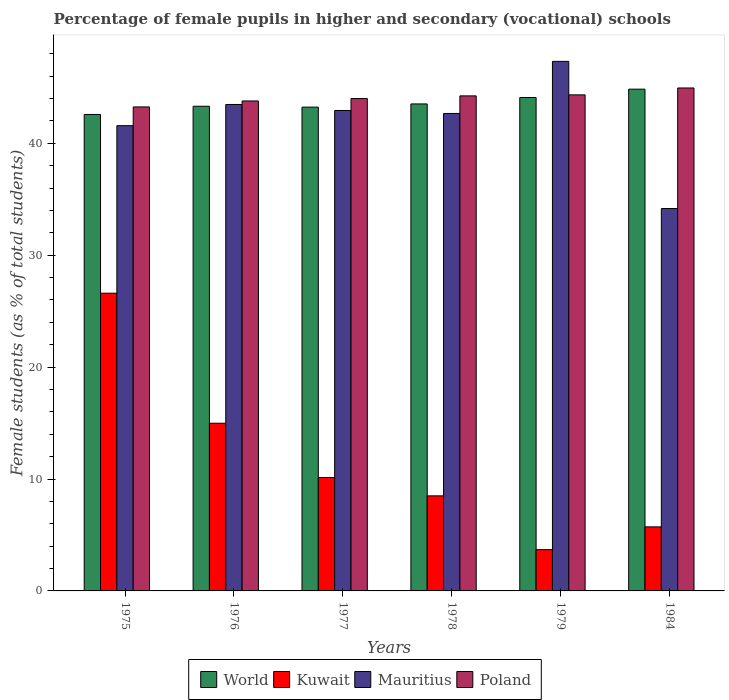How many different coloured bars are there?
Your answer should be compact. 4. How many groups of bars are there?
Your answer should be very brief. 6. Are the number of bars per tick equal to the number of legend labels?
Give a very brief answer. Yes. Are the number of bars on each tick of the X-axis equal?
Your response must be concise. Yes. How many bars are there on the 1st tick from the left?
Make the answer very short. 4. In how many cases, is the number of bars for a given year not equal to the number of legend labels?
Make the answer very short. 0. What is the percentage of female pupils in higher and secondary schools in Mauritius in 1984?
Your response must be concise. 34.17. Across all years, what is the maximum percentage of female pupils in higher and secondary schools in Kuwait?
Offer a terse response. 26.61. Across all years, what is the minimum percentage of female pupils in higher and secondary schools in Mauritius?
Offer a very short reply. 34.17. In which year was the percentage of female pupils in higher and secondary schools in Kuwait maximum?
Your answer should be compact. 1975. In which year was the percentage of female pupils in higher and secondary schools in Kuwait minimum?
Your answer should be compact. 1979. What is the total percentage of female pupils in higher and secondary schools in Poland in the graph?
Ensure brevity in your answer.  264.57. What is the difference between the percentage of female pupils in higher and secondary schools in Kuwait in 1976 and that in 1984?
Your response must be concise. 9.26. What is the difference between the percentage of female pupils in higher and secondary schools in Poland in 1978 and the percentage of female pupils in higher and secondary schools in World in 1979?
Give a very brief answer. 0.15. What is the average percentage of female pupils in higher and secondary schools in Poland per year?
Your answer should be very brief. 44.09. In the year 1977, what is the difference between the percentage of female pupils in higher and secondary schools in Poland and percentage of female pupils in higher and secondary schools in World?
Provide a short and direct response. 0.77. In how many years, is the percentage of female pupils in higher and secondary schools in Kuwait greater than 40 %?
Offer a terse response. 0. What is the ratio of the percentage of female pupils in higher and secondary schools in World in 1978 to that in 1984?
Provide a short and direct response. 0.97. Is the percentage of female pupils in higher and secondary schools in Kuwait in 1975 less than that in 1978?
Your response must be concise. No. Is the difference between the percentage of female pupils in higher and secondary schools in Poland in 1977 and 1984 greater than the difference between the percentage of female pupils in higher and secondary schools in World in 1977 and 1984?
Your answer should be compact. Yes. What is the difference between the highest and the second highest percentage of female pupils in higher and secondary schools in Mauritius?
Offer a terse response. 3.85. What is the difference between the highest and the lowest percentage of female pupils in higher and secondary schools in Kuwait?
Ensure brevity in your answer.  22.92. Is it the case that in every year, the sum of the percentage of female pupils in higher and secondary schools in Mauritius and percentage of female pupils in higher and secondary schools in Kuwait is greater than the sum of percentage of female pupils in higher and secondary schools in World and percentage of female pupils in higher and secondary schools in Poland?
Provide a short and direct response. No. What does the 1st bar from the left in 1975 represents?
Ensure brevity in your answer.  World. How many bars are there?
Your answer should be compact. 24. Are the values on the major ticks of Y-axis written in scientific E-notation?
Keep it short and to the point. No. Does the graph contain any zero values?
Make the answer very short. No. Does the graph contain grids?
Give a very brief answer. No. What is the title of the graph?
Give a very brief answer. Percentage of female pupils in higher and secondary (vocational) schools. Does "Faeroe Islands" appear as one of the legend labels in the graph?
Your answer should be compact. No. What is the label or title of the X-axis?
Offer a very short reply. Years. What is the label or title of the Y-axis?
Give a very brief answer. Female students (as % of total students). What is the Female students (as % of total students) of World in 1975?
Provide a short and direct response. 42.58. What is the Female students (as % of total students) in Kuwait in 1975?
Provide a succinct answer. 26.61. What is the Female students (as % of total students) of Mauritius in 1975?
Provide a succinct answer. 41.58. What is the Female students (as % of total students) of Poland in 1975?
Ensure brevity in your answer.  43.25. What is the Female students (as % of total students) of World in 1976?
Your answer should be very brief. 43.31. What is the Female students (as % of total students) of Kuwait in 1976?
Your answer should be very brief. 14.98. What is the Female students (as % of total students) in Mauritius in 1976?
Give a very brief answer. 43.47. What is the Female students (as % of total students) of Poland in 1976?
Provide a succinct answer. 43.79. What is the Female students (as % of total students) of World in 1977?
Offer a terse response. 43.24. What is the Female students (as % of total students) of Kuwait in 1977?
Offer a terse response. 10.14. What is the Female students (as % of total students) of Mauritius in 1977?
Your answer should be very brief. 42.94. What is the Female students (as % of total students) of Poland in 1977?
Provide a succinct answer. 44. What is the Female students (as % of total students) in World in 1978?
Provide a succinct answer. 43.52. What is the Female students (as % of total students) in Kuwait in 1978?
Your answer should be very brief. 8.5. What is the Female students (as % of total students) in Mauritius in 1978?
Your answer should be compact. 42.67. What is the Female students (as % of total students) of Poland in 1978?
Your answer should be compact. 44.24. What is the Female students (as % of total students) of World in 1979?
Provide a short and direct response. 44.1. What is the Female students (as % of total students) of Kuwait in 1979?
Your answer should be very brief. 3.69. What is the Female students (as % of total students) of Mauritius in 1979?
Make the answer very short. 47.33. What is the Female students (as % of total students) of Poland in 1979?
Keep it short and to the point. 44.33. What is the Female students (as % of total students) in World in 1984?
Make the answer very short. 44.84. What is the Female students (as % of total students) of Kuwait in 1984?
Your response must be concise. 5.72. What is the Female students (as % of total students) in Mauritius in 1984?
Give a very brief answer. 34.17. What is the Female students (as % of total students) in Poland in 1984?
Provide a short and direct response. 44.95. Across all years, what is the maximum Female students (as % of total students) of World?
Provide a short and direct response. 44.84. Across all years, what is the maximum Female students (as % of total students) in Kuwait?
Give a very brief answer. 26.61. Across all years, what is the maximum Female students (as % of total students) of Mauritius?
Offer a terse response. 47.33. Across all years, what is the maximum Female students (as % of total students) of Poland?
Offer a very short reply. 44.95. Across all years, what is the minimum Female students (as % of total students) of World?
Provide a succinct answer. 42.58. Across all years, what is the minimum Female students (as % of total students) in Kuwait?
Provide a short and direct response. 3.69. Across all years, what is the minimum Female students (as % of total students) in Mauritius?
Offer a very short reply. 34.17. Across all years, what is the minimum Female students (as % of total students) in Poland?
Offer a terse response. 43.25. What is the total Female students (as % of total students) of World in the graph?
Your answer should be compact. 261.59. What is the total Female students (as % of total students) of Kuwait in the graph?
Offer a terse response. 69.64. What is the total Female students (as % of total students) in Mauritius in the graph?
Make the answer very short. 252.16. What is the total Female students (as % of total students) of Poland in the graph?
Offer a very short reply. 264.57. What is the difference between the Female students (as % of total students) of World in 1975 and that in 1976?
Offer a very short reply. -0.73. What is the difference between the Female students (as % of total students) in Kuwait in 1975 and that in 1976?
Ensure brevity in your answer.  11.62. What is the difference between the Female students (as % of total students) in Mauritius in 1975 and that in 1976?
Give a very brief answer. -1.89. What is the difference between the Female students (as % of total students) of Poland in 1975 and that in 1976?
Offer a very short reply. -0.53. What is the difference between the Female students (as % of total students) of World in 1975 and that in 1977?
Offer a terse response. -0.66. What is the difference between the Female students (as % of total students) of Kuwait in 1975 and that in 1977?
Ensure brevity in your answer.  16.47. What is the difference between the Female students (as % of total students) of Mauritius in 1975 and that in 1977?
Provide a succinct answer. -1.36. What is the difference between the Female students (as % of total students) in Poland in 1975 and that in 1977?
Offer a very short reply. -0.75. What is the difference between the Female students (as % of total students) in World in 1975 and that in 1978?
Your response must be concise. -0.94. What is the difference between the Female students (as % of total students) in Kuwait in 1975 and that in 1978?
Ensure brevity in your answer.  18.11. What is the difference between the Female students (as % of total students) in Mauritius in 1975 and that in 1978?
Provide a short and direct response. -1.09. What is the difference between the Female students (as % of total students) in Poland in 1975 and that in 1978?
Ensure brevity in your answer.  -0.99. What is the difference between the Female students (as % of total students) of World in 1975 and that in 1979?
Offer a very short reply. -1.52. What is the difference between the Female students (as % of total students) in Kuwait in 1975 and that in 1979?
Your response must be concise. 22.92. What is the difference between the Female students (as % of total students) of Mauritius in 1975 and that in 1979?
Offer a very short reply. -5.75. What is the difference between the Female students (as % of total students) in Poland in 1975 and that in 1979?
Ensure brevity in your answer.  -1.08. What is the difference between the Female students (as % of total students) in World in 1975 and that in 1984?
Offer a very short reply. -2.26. What is the difference between the Female students (as % of total students) of Kuwait in 1975 and that in 1984?
Provide a succinct answer. 20.88. What is the difference between the Female students (as % of total students) of Mauritius in 1975 and that in 1984?
Provide a succinct answer. 7.41. What is the difference between the Female students (as % of total students) in Poland in 1975 and that in 1984?
Provide a short and direct response. -1.69. What is the difference between the Female students (as % of total students) of World in 1976 and that in 1977?
Keep it short and to the point. 0.08. What is the difference between the Female students (as % of total students) of Kuwait in 1976 and that in 1977?
Provide a short and direct response. 4.85. What is the difference between the Female students (as % of total students) in Mauritius in 1976 and that in 1977?
Ensure brevity in your answer.  0.54. What is the difference between the Female students (as % of total students) of Poland in 1976 and that in 1977?
Your answer should be very brief. -0.22. What is the difference between the Female students (as % of total students) in World in 1976 and that in 1978?
Offer a very short reply. -0.21. What is the difference between the Female students (as % of total students) in Kuwait in 1976 and that in 1978?
Provide a succinct answer. 6.49. What is the difference between the Female students (as % of total students) of Mauritius in 1976 and that in 1978?
Provide a short and direct response. 0.8. What is the difference between the Female students (as % of total students) in Poland in 1976 and that in 1978?
Your response must be concise. -0.45. What is the difference between the Female students (as % of total students) in World in 1976 and that in 1979?
Provide a succinct answer. -0.78. What is the difference between the Female students (as % of total students) of Kuwait in 1976 and that in 1979?
Give a very brief answer. 11.3. What is the difference between the Female students (as % of total students) in Mauritius in 1976 and that in 1979?
Make the answer very short. -3.85. What is the difference between the Female students (as % of total students) in Poland in 1976 and that in 1979?
Provide a succinct answer. -0.54. What is the difference between the Female students (as % of total students) in World in 1976 and that in 1984?
Offer a terse response. -1.53. What is the difference between the Female students (as % of total students) in Kuwait in 1976 and that in 1984?
Ensure brevity in your answer.  9.26. What is the difference between the Female students (as % of total students) in Mauritius in 1976 and that in 1984?
Offer a very short reply. 9.3. What is the difference between the Female students (as % of total students) of Poland in 1976 and that in 1984?
Your answer should be compact. -1.16. What is the difference between the Female students (as % of total students) of World in 1977 and that in 1978?
Provide a short and direct response. -0.28. What is the difference between the Female students (as % of total students) in Kuwait in 1977 and that in 1978?
Keep it short and to the point. 1.64. What is the difference between the Female students (as % of total students) of Mauritius in 1977 and that in 1978?
Your answer should be compact. 0.27. What is the difference between the Female students (as % of total students) of Poland in 1977 and that in 1978?
Make the answer very short. -0.24. What is the difference between the Female students (as % of total students) of World in 1977 and that in 1979?
Offer a very short reply. -0.86. What is the difference between the Female students (as % of total students) of Kuwait in 1977 and that in 1979?
Your answer should be very brief. 6.45. What is the difference between the Female students (as % of total students) of Mauritius in 1977 and that in 1979?
Ensure brevity in your answer.  -4.39. What is the difference between the Female students (as % of total students) in Poland in 1977 and that in 1979?
Provide a short and direct response. -0.33. What is the difference between the Female students (as % of total students) of World in 1977 and that in 1984?
Give a very brief answer. -1.6. What is the difference between the Female students (as % of total students) in Kuwait in 1977 and that in 1984?
Ensure brevity in your answer.  4.41. What is the difference between the Female students (as % of total students) of Mauritius in 1977 and that in 1984?
Provide a short and direct response. 8.76. What is the difference between the Female students (as % of total students) in Poland in 1977 and that in 1984?
Give a very brief answer. -0.94. What is the difference between the Female students (as % of total students) in World in 1978 and that in 1979?
Provide a short and direct response. -0.57. What is the difference between the Female students (as % of total students) of Kuwait in 1978 and that in 1979?
Your answer should be compact. 4.81. What is the difference between the Female students (as % of total students) in Mauritius in 1978 and that in 1979?
Keep it short and to the point. -4.66. What is the difference between the Female students (as % of total students) in Poland in 1978 and that in 1979?
Offer a very short reply. -0.09. What is the difference between the Female students (as % of total students) of World in 1978 and that in 1984?
Make the answer very short. -1.32. What is the difference between the Female students (as % of total students) of Kuwait in 1978 and that in 1984?
Ensure brevity in your answer.  2.77. What is the difference between the Female students (as % of total students) of Mauritius in 1978 and that in 1984?
Your response must be concise. 8.5. What is the difference between the Female students (as % of total students) of Poland in 1978 and that in 1984?
Provide a succinct answer. -0.71. What is the difference between the Female students (as % of total students) of World in 1979 and that in 1984?
Make the answer very short. -0.75. What is the difference between the Female students (as % of total students) in Kuwait in 1979 and that in 1984?
Ensure brevity in your answer.  -2.04. What is the difference between the Female students (as % of total students) in Mauritius in 1979 and that in 1984?
Your answer should be very brief. 13.15. What is the difference between the Female students (as % of total students) in Poland in 1979 and that in 1984?
Make the answer very short. -0.62. What is the difference between the Female students (as % of total students) in World in 1975 and the Female students (as % of total students) in Kuwait in 1976?
Make the answer very short. 27.6. What is the difference between the Female students (as % of total students) of World in 1975 and the Female students (as % of total students) of Mauritius in 1976?
Give a very brief answer. -0.89. What is the difference between the Female students (as % of total students) in World in 1975 and the Female students (as % of total students) in Poland in 1976?
Provide a succinct answer. -1.21. What is the difference between the Female students (as % of total students) in Kuwait in 1975 and the Female students (as % of total students) in Mauritius in 1976?
Offer a very short reply. -16.87. What is the difference between the Female students (as % of total students) of Kuwait in 1975 and the Female students (as % of total students) of Poland in 1976?
Give a very brief answer. -17.18. What is the difference between the Female students (as % of total students) in Mauritius in 1975 and the Female students (as % of total students) in Poland in 1976?
Your answer should be compact. -2.21. What is the difference between the Female students (as % of total students) of World in 1975 and the Female students (as % of total students) of Kuwait in 1977?
Offer a terse response. 32.45. What is the difference between the Female students (as % of total students) in World in 1975 and the Female students (as % of total students) in Mauritius in 1977?
Provide a short and direct response. -0.36. What is the difference between the Female students (as % of total students) of World in 1975 and the Female students (as % of total students) of Poland in 1977?
Your response must be concise. -1.42. What is the difference between the Female students (as % of total students) of Kuwait in 1975 and the Female students (as % of total students) of Mauritius in 1977?
Keep it short and to the point. -16.33. What is the difference between the Female students (as % of total students) in Kuwait in 1975 and the Female students (as % of total students) in Poland in 1977?
Offer a terse response. -17.4. What is the difference between the Female students (as % of total students) of Mauritius in 1975 and the Female students (as % of total students) of Poland in 1977?
Provide a succinct answer. -2.42. What is the difference between the Female students (as % of total students) in World in 1975 and the Female students (as % of total students) in Kuwait in 1978?
Provide a short and direct response. 34.09. What is the difference between the Female students (as % of total students) in World in 1975 and the Female students (as % of total students) in Mauritius in 1978?
Make the answer very short. -0.09. What is the difference between the Female students (as % of total students) of World in 1975 and the Female students (as % of total students) of Poland in 1978?
Your answer should be compact. -1.66. What is the difference between the Female students (as % of total students) in Kuwait in 1975 and the Female students (as % of total students) in Mauritius in 1978?
Give a very brief answer. -16.06. What is the difference between the Female students (as % of total students) of Kuwait in 1975 and the Female students (as % of total students) of Poland in 1978?
Give a very brief answer. -17.63. What is the difference between the Female students (as % of total students) of Mauritius in 1975 and the Female students (as % of total students) of Poland in 1978?
Make the answer very short. -2.66. What is the difference between the Female students (as % of total students) of World in 1975 and the Female students (as % of total students) of Kuwait in 1979?
Provide a succinct answer. 38.89. What is the difference between the Female students (as % of total students) of World in 1975 and the Female students (as % of total students) of Mauritius in 1979?
Provide a short and direct response. -4.75. What is the difference between the Female students (as % of total students) of World in 1975 and the Female students (as % of total students) of Poland in 1979?
Offer a very short reply. -1.75. What is the difference between the Female students (as % of total students) in Kuwait in 1975 and the Female students (as % of total students) in Mauritius in 1979?
Provide a succinct answer. -20.72. What is the difference between the Female students (as % of total students) of Kuwait in 1975 and the Female students (as % of total students) of Poland in 1979?
Your response must be concise. -17.72. What is the difference between the Female students (as % of total students) in Mauritius in 1975 and the Female students (as % of total students) in Poland in 1979?
Ensure brevity in your answer.  -2.75. What is the difference between the Female students (as % of total students) in World in 1975 and the Female students (as % of total students) in Kuwait in 1984?
Keep it short and to the point. 36.86. What is the difference between the Female students (as % of total students) in World in 1975 and the Female students (as % of total students) in Mauritius in 1984?
Keep it short and to the point. 8.41. What is the difference between the Female students (as % of total students) of World in 1975 and the Female students (as % of total students) of Poland in 1984?
Ensure brevity in your answer.  -2.37. What is the difference between the Female students (as % of total students) in Kuwait in 1975 and the Female students (as % of total students) in Mauritius in 1984?
Give a very brief answer. -7.56. What is the difference between the Female students (as % of total students) in Kuwait in 1975 and the Female students (as % of total students) in Poland in 1984?
Your response must be concise. -18.34. What is the difference between the Female students (as % of total students) in Mauritius in 1975 and the Female students (as % of total students) in Poland in 1984?
Offer a very short reply. -3.37. What is the difference between the Female students (as % of total students) in World in 1976 and the Female students (as % of total students) in Kuwait in 1977?
Make the answer very short. 33.18. What is the difference between the Female students (as % of total students) in World in 1976 and the Female students (as % of total students) in Mauritius in 1977?
Make the answer very short. 0.38. What is the difference between the Female students (as % of total students) of World in 1976 and the Female students (as % of total students) of Poland in 1977?
Make the answer very short. -0.69. What is the difference between the Female students (as % of total students) in Kuwait in 1976 and the Female students (as % of total students) in Mauritius in 1977?
Offer a terse response. -27.95. What is the difference between the Female students (as % of total students) in Kuwait in 1976 and the Female students (as % of total students) in Poland in 1977?
Offer a very short reply. -29.02. What is the difference between the Female students (as % of total students) of Mauritius in 1976 and the Female students (as % of total students) of Poland in 1977?
Your answer should be very brief. -0.53. What is the difference between the Female students (as % of total students) in World in 1976 and the Female students (as % of total students) in Kuwait in 1978?
Offer a very short reply. 34.82. What is the difference between the Female students (as % of total students) in World in 1976 and the Female students (as % of total students) in Mauritius in 1978?
Provide a short and direct response. 0.64. What is the difference between the Female students (as % of total students) in World in 1976 and the Female students (as % of total students) in Poland in 1978?
Keep it short and to the point. -0.93. What is the difference between the Female students (as % of total students) of Kuwait in 1976 and the Female students (as % of total students) of Mauritius in 1978?
Keep it short and to the point. -27.68. What is the difference between the Female students (as % of total students) in Kuwait in 1976 and the Female students (as % of total students) in Poland in 1978?
Provide a succinct answer. -29.26. What is the difference between the Female students (as % of total students) of Mauritius in 1976 and the Female students (as % of total students) of Poland in 1978?
Give a very brief answer. -0.77. What is the difference between the Female students (as % of total students) of World in 1976 and the Female students (as % of total students) of Kuwait in 1979?
Keep it short and to the point. 39.63. What is the difference between the Female students (as % of total students) in World in 1976 and the Female students (as % of total students) in Mauritius in 1979?
Your response must be concise. -4.01. What is the difference between the Female students (as % of total students) of World in 1976 and the Female students (as % of total students) of Poland in 1979?
Offer a very short reply. -1.02. What is the difference between the Female students (as % of total students) in Kuwait in 1976 and the Female students (as % of total students) in Mauritius in 1979?
Give a very brief answer. -32.34. What is the difference between the Female students (as % of total students) of Kuwait in 1976 and the Female students (as % of total students) of Poland in 1979?
Provide a succinct answer. -29.35. What is the difference between the Female students (as % of total students) of Mauritius in 1976 and the Female students (as % of total students) of Poland in 1979?
Your answer should be compact. -0.86. What is the difference between the Female students (as % of total students) in World in 1976 and the Female students (as % of total students) in Kuwait in 1984?
Give a very brief answer. 37.59. What is the difference between the Female students (as % of total students) of World in 1976 and the Female students (as % of total students) of Mauritius in 1984?
Keep it short and to the point. 9.14. What is the difference between the Female students (as % of total students) of World in 1976 and the Female students (as % of total students) of Poland in 1984?
Ensure brevity in your answer.  -1.63. What is the difference between the Female students (as % of total students) in Kuwait in 1976 and the Female students (as % of total students) in Mauritius in 1984?
Offer a terse response. -19.19. What is the difference between the Female students (as % of total students) in Kuwait in 1976 and the Female students (as % of total students) in Poland in 1984?
Give a very brief answer. -29.96. What is the difference between the Female students (as % of total students) in Mauritius in 1976 and the Female students (as % of total students) in Poland in 1984?
Make the answer very short. -1.47. What is the difference between the Female students (as % of total students) in World in 1977 and the Female students (as % of total students) in Kuwait in 1978?
Give a very brief answer. 34.74. What is the difference between the Female students (as % of total students) of World in 1977 and the Female students (as % of total students) of Mauritius in 1978?
Give a very brief answer. 0.57. What is the difference between the Female students (as % of total students) in World in 1977 and the Female students (as % of total students) in Poland in 1978?
Provide a short and direct response. -1. What is the difference between the Female students (as % of total students) of Kuwait in 1977 and the Female students (as % of total students) of Mauritius in 1978?
Keep it short and to the point. -32.53. What is the difference between the Female students (as % of total students) of Kuwait in 1977 and the Female students (as % of total students) of Poland in 1978?
Make the answer very short. -34.11. What is the difference between the Female students (as % of total students) of Mauritius in 1977 and the Female students (as % of total students) of Poland in 1978?
Provide a succinct answer. -1.3. What is the difference between the Female students (as % of total students) of World in 1977 and the Female students (as % of total students) of Kuwait in 1979?
Make the answer very short. 39.55. What is the difference between the Female students (as % of total students) in World in 1977 and the Female students (as % of total students) in Mauritius in 1979?
Offer a terse response. -4.09. What is the difference between the Female students (as % of total students) in World in 1977 and the Female students (as % of total students) in Poland in 1979?
Make the answer very short. -1.09. What is the difference between the Female students (as % of total students) in Kuwait in 1977 and the Female students (as % of total students) in Mauritius in 1979?
Give a very brief answer. -37.19. What is the difference between the Female students (as % of total students) of Kuwait in 1977 and the Female students (as % of total students) of Poland in 1979?
Provide a short and direct response. -34.2. What is the difference between the Female students (as % of total students) of Mauritius in 1977 and the Female students (as % of total students) of Poland in 1979?
Offer a terse response. -1.39. What is the difference between the Female students (as % of total students) of World in 1977 and the Female students (as % of total students) of Kuwait in 1984?
Make the answer very short. 37.51. What is the difference between the Female students (as % of total students) in World in 1977 and the Female students (as % of total students) in Mauritius in 1984?
Make the answer very short. 9.06. What is the difference between the Female students (as % of total students) in World in 1977 and the Female students (as % of total students) in Poland in 1984?
Your answer should be compact. -1.71. What is the difference between the Female students (as % of total students) in Kuwait in 1977 and the Female students (as % of total students) in Mauritius in 1984?
Your answer should be compact. -24.04. What is the difference between the Female students (as % of total students) of Kuwait in 1977 and the Female students (as % of total students) of Poland in 1984?
Offer a very short reply. -34.81. What is the difference between the Female students (as % of total students) of Mauritius in 1977 and the Female students (as % of total students) of Poland in 1984?
Offer a terse response. -2.01. What is the difference between the Female students (as % of total students) in World in 1978 and the Female students (as % of total students) in Kuwait in 1979?
Offer a terse response. 39.83. What is the difference between the Female students (as % of total students) in World in 1978 and the Female students (as % of total students) in Mauritius in 1979?
Your response must be concise. -3.8. What is the difference between the Female students (as % of total students) of World in 1978 and the Female students (as % of total students) of Poland in 1979?
Make the answer very short. -0.81. What is the difference between the Female students (as % of total students) of Kuwait in 1978 and the Female students (as % of total students) of Mauritius in 1979?
Your response must be concise. -38.83. What is the difference between the Female students (as % of total students) in Kuwait in 1978 and the Female students (as % of total students) in Poland in 1979?
Your answer should be very brief. -35.84. What is the difference between the Female students (as % of total students) of Mauritius in 1978 and the Female students (as % of total students) of Poland in 1979?
Your answer should be compact. -1.66. What is the difference between the Female students (as % of total students) of World in 1978 and the Female students (as % of total students) of Kuwait in 1984?
Ensure brevity in your answer.  37.8. What is the difference between the Female students (as % of total students) of World in 1978 and the Female students (as % of total students) of Mauritius in 1984?
Your response must be concise. 9.35. What is the difference between the Female students (as % of total students) in World in 1978 and the Female students (as % of total students) in Poland in 1984?
Keep it short and to the point. -1.43. What is the difference between the Female students (as % of total students) of Kuwait in 1978 and the Female students (as % of total students) of Mauritius in 1984?
Offer a terse response. -25.68. What is the difference between the Female students (as % of total students) in Kuwait in 1978 and the Female students (as % of total students) in Poland in 1984?
Keep it short and to the point. -36.45. What is the difference between the Female students (as % of total students) of Mauritius in 1978 and the Female students (as % of total students) of Poland in 1984?
Offer a very short reply. -2.28. What is the difference between the Female students (as % of total students) in World in 1979 and the Female students (as % of total students) in Kuwait in 1984?
Provide a short and direct response. 38.37. What is the difference between the Female students (as % of total students) of World in 1979 and the Female students (as % of total students) of Mauritius in 1984?
Keep it short and to the point. 9.92. What is the difference between the Female students (as % of total students) of World in 1979 and the Female students (as % of total students) of Poland in 1984?
Your response must be concise. -0.85. What is the difference between the Female students (as % of total students) of Kuwait in 1979 and the Female students (as % of total students) of Mauritius in 1984?
Your response must be concise. -30.48. What is the difference between the Female students (as % of total students) in Kuwait in 1979 and the Female students (as % of total students) in Poland in 1984?
Provide a succinct answer. -41.26. What is the difference between the Female students (as % of total students) of Mauritius in 1979 and the Female students (as % of total students) of Poland in 1984?
Ensure brevity in your answer.  2.38. What is the average Female students (as % of total students) of World per year?
Make the answer very short. 43.6. What is the average Female students (as % of total students) of Kuwait per year?
Your response must be concise. 11.61. What is the average Female students (as % of total students) of Mauritius per year?
Your answer should be very brief. 42.03. What is the average Female students (as % of total students) of Poland per year?
Your answer should be compact. 44.09. In the year 1975, what is the difference between the Female students (as % of total students) in World and Female students (as % of total students) in Kuwait?
Your answer should be very brief. 15.97. In the year 1975, what is the difference between the Female students (as % of total students) in World and Female students (as % of total students) in Poland?
Ensure brevity in your answer.  -0.67. In the year 1975, what is the difference between the Female students (as % of total students) in Kuwait and Female students (as % of total students) in Mauritius?
Provide a succinct answer. -14.97. In the year 1975, what is the difference between the Female students (as % of total students) of Kuwait and Female students (as % of total students) of Poland?
Offer a terse response. -16.65. In the year 1975, what is the difference between the Female students (as % of total students) in Mauritius and Female students (as % of total students) in Poland?
Your answer should be very brief. -1.67. In the year 1976, what is the difference between the Female students (as % of total students) of World and Female students (as % of total students) of Kuwait?
Your answer should be compact. 28.33. In the year 1976, what is the difference between the Female students (as % of total students) of World and Female students (as % of total students) of Mauritius?
Ensure brevity in your answer.  -0.16. In the year 1976, what is the difference between the Female students (as % of total students) in World and Female students (as % of total students) in Poland?
Make the answer very short. -0.47. In the year 1976, what is the difference between the Female students (as % of total students) in Kuwait and Female students (as % of total students) in Mauritius?
Keep it short and to the point. -28.49. In the year 1976, what is the difference between the Female students (as % of total students) in Kuwait and Female students (as % of total students) in Poland?
Offer a very short reply. -28.8. In the year 1976, what is the difference between the Female students (as % of total students) in Mauritius and Female students (as % of total students) in Poland?
Keep it short and to the point. -0.31. In the year 1977, what is the difference between the Female students (as % of total students) of World and Female students (as % of total students) of Kuwait?
Give a very brief answer. 33.1. In the year 1977, what is the difference between the Female students (as % of total students) in World and Female students (as % of total students) in Mauritius?
Your answer should be very brief. 0.3. In the year 1977, what is the difference between the Female students (as % of total students) in World and Female students (as % of total students) in Poland?
Ensure brevity in your answer.  -0.77. In the year 1977, what is the difference between the Female students (as % of total students) of Kuwait and Female students (as % of total students) of Mauritius?
Offer a very short reply. -32.8. In the year 1977, what is the difference between the Female students (as % of total students) in Kuwait and Female students (as % of total students) in Poland?
Your answer should be very brief. -33.87. In the year 1977, what is the difference between the Female students (as % of total students) in Mauritius and Female students (as % of total students) in Poland?
Your response must be concise. -1.07. In the year 1978, what is the difference between the Female students (as % of total students) of World and Female students (as % of total students) of Kuwait?
Your answer should be compact. 35.03. In the year 1978, what is the difference between the Female students (as % of total students) in World and Female students (as % of total students) in Mauritius?
Your answer should be compact. 0.85. In the year 1978, what is the difference between the Female students (as % of total students) of World and Female students (as % of total students) of Poland?
Offer a terse response. -0.72. In the year 1978, what is the difference between the Female students (as % of total students) in Kuwait and Female students (as % of total students) in Mauritius?
Make the answer very short. -34.17. In the year 1978, what is the difference between the Female students (as % of total students) in Kuwait and Female students (as % of total students) in Poland?
Give a very brief answer. -35.75. In the year 1978, what is the difference between the Female students (as % of total students) of Mauritius and Female students (as % of total students) of Poland?
Provide a succinct answer. -1.57. In the year 1979, what is the difference between the Female students (as % of total students) of World and Female students (as % of total students) of Kuwait?
Ensure brevity in your answer.  40.41. In the year 1979, what is the difference between the Female students (as % of total students) of World and Female students (as % of total students) of Mauritius?
Keep it short and to the point. -3.23. In the year 1979, what is the difference between the Female students (as % of total students) of World and Female students (as % of total students) of Poland?
Provide a succinct answer. -0.24. In the year 1979, what is the difference between the Female students (as % of total students) of Kuwait and Female students (as % of total students) of Mauritius?
Keep it short and to the point. -43.64. In the year 1979, what is the difference between the Female students (as % of total students) of Kuwait and Female students (as % of total students) of Poland?
Make the answer very short. -40.64. In the year 1979, what is the difference between the Female students (as % of total students) in Mauritius and Female students (as % of total students) in Poland?
Your response must be concise. 3. In the year 1984, what is the difference between the Female students (as % of total students) of World and Female students (as % of total students) of Kuwait?
Keep it short and to the point. 39.12. In the year 1984, what is the difference between the Female students (as % of total students) of World and Female students (as % of total students) of Mauritius?
Make the answer very short. 10.67. In the year 1984, what is the difference between the Female students (as % of total students) of World and Female students (as % of total students) of Poland?
Your answer should be compact. -0.11. In the year 1984, what is the difference between the Female students (as % of total students) in Kuwait and Female students (as % of total students) in Mauritius?
Your answer should be very brief. -28.45. In the year 1984, what is the difference between the Female students (as % of total students) of Kuwait and Female students (as % of total students) of Poland?
Provide a succinct answer. -39.22. In the year 1984, what is the difference between the Female students (as % of total students) of Mauritius and Female students (as % of total students) of Poland?
Provide a short and direct response. -10.77. What is the ratio of the Female students (as % of total students) of World in 1975 to that in 1976?
Offer a terse response. 0.98. What is the ratio of the Female students (as % of total students) of Kuwait in 1975 to that in 1976?
Your response must be concise. 1.78. What is the ratio of the Female students (as % of total students) of Mauritius in 1975 to that in 1976?
Provide a short and direct response. 0.96. What is the ratio of the Female students (as % of total students) in Poland in 1975 to that in 1976?
Your answer should be compact. 0.99. What is the ratio of the Female students (as % of total students) in World in 1975 to that in 1977?
Offer a very short reply. 0.98. What is the ratio of the Female students (as % of total students) of Kuwait in 1975 to that in 1977?
Offer a very short reply. 2.63. What is the ratio of the Female students (as % of total students) of Mauritius in 1975 to that in 1977?
Provide a succinct answer. 0.97. What is the ratio of the Female students (as % of total students) of Poland in 1975 to that in 1977?
Provide a succinct answer. 0.98. What is the ratio of the Female students (as % of total students) of World in 1975 to that in 1978?
Provide a succinct answer. 0.98. What is the ratio of the Female students (as % of total students) of Kuwait in 1975 to that in 1978?
Offer a very short reply. 3.13. What is the ratio of the Female students (as % of total students) in Mauritius in 1975 to that in 1978?
Make the answer very short. 0.97. What is the ratio of the Female students (as % of total students) in Poland in 1975 to that in 1978?
Your response must be concise. 0.98. What is the ratio of the Female students (as % of total students) of World in 1975 to that in 1979?
Keep it short and to the point. 0.97. What is the ratio of the Female students (as % of total students) in Kuwait in 1975 to that in 1979?
Provide a short and direct response. 7.21. What is the ratio of the Female students (as % of total students) in Mauritius in 1975 to that in 1979?
Ensure brevity in your answer.  0.88. What is the ratio of the Female students (as % of total students) of Poland in 1975 to that in 1979?
Your response must be concise. 0.98. What is the ratio of the Female students (as % of total students) in World in 1975 to that in 1984?
Offer a very short reply. 0.95. What is the ratio of the Female students (as % of total students) in Kuwait in 1975 to that in 1984?
Give a very brief answer. 4.65. What is the ratio of the Female students (as % of total students) of Mauritius in 1975 to that in 1984?
Make the answer very short. 1.22. What is the ratio of the Female students (as % of total students) in Poland in 1975 to that in 1984?
Offer a terse response. 0.96. What is the ratio of the Female students (as % of total students) in Kuwait in 1976 to that in 1977?
Ensure brevity in your answer.  1.48. What is the ratio of the Female students (as % of total students) in Mauritius in 1976 to that in 1977?
Make the answer very short. 1.01. What is the ratio of the Female students (as % of total students) of World in 1976 to that in 1978?
Ensure brevity in your answer.  1. What is the ratio of the Female students (as % of total students) of Kuwait in 1976 to that in 1978?
Provide a succinct answer. 1.76. What is the ratio of the Female students (as % of total students) of Mauritius in 1976 to that in 1978?
Your answer should be compact. 1.02. What is the ratio of the Female students (as % of total students) in World in 1976 to that in 1979?
Give a very brief answer. 0.98. What is the ratio of the Female students (as % of total students) of Kuwait in 1976 to that in 1979?
Give a very brief answer. 4.06. What is the ratio of the Female students (as % of total students) in Mauritius in 1976 to that in 1979?
Your answer should be compact. 0.92. What is the ratio of the Female students (as % of total students) in World in 1976 to that in 1984?
Provide a succinct answer. 0.97. What is the ratio of the Female students (as % of total students) in Kuwait in 1976 to that in 1984?
Offer a very short reply. 2.62. What is the ratio of the Female students (as % of total students) of Mauritius in 1976 to that in 1984?
Your response must be concise. 1.27. What is the ratio of the Female students (as % of total students) of Poland in 1976 to that in 1984?
Ensure brevity in your answer.  0.97. What is the ratio of the Female students (as % of total students) in Kuwait in 1977 to that in 1978?
Provide a succinct answer. 1.19. What is the ratio of the Female students (as % of total students) of World in 1977 to that in 1979?
Offer a terse response. 0.98. What is the ratio of the Female students (as % of total students) in Kuwait in 1977 to that in 1979?
Your answer should be very brief. 2.75. What is the ratio of the Female students (as % of total students) of Mauritius in 1977 to that in 1979?
Provide a succinct answer. 0.91. What is the ratio of the Female students (as % of total students) of Poland in 1977 to that in 1979?
Provide a succinct answer. 0.99. What is the ratio of the Female students (as % of total students) in World in 1977 to that in 1984?
Offer a terse response. 0.96. What is the ratio of the Female students (as % of total students) in Kuwait in 1977 to that in 1984?
Your response must be concise. 1.77. What is the ratio of the Female students (as % of total students) in Mauritius in 1977 to that in 1984?
Offer a terse response. 1.26. What is the ratio of the Female students (as % of total students) of Poland in 1977 to that in 1984?
Your answer should be very brief. 0.98. What is the ratio of the Female students (as % of total students) in World in 1978 to that in 1979?
Give a very brief answer. 0.99. What is the ratio of the Female students (as % of total students) in Kuwait in 1978 to that in 1979?
Your response must be concise. 2.3. What is the ratio of the Female students (as % of total students) in Mauritius in 1978 to that in 1979?
Provide a succinct answer. 0.9. What is the ratio of the Female students (as % of total students) in Poland in 1978 to that in 1979?
Offer a very short reply. 1. What is the ratio of the Female students (as % of total students) in World in 1978 to that in 1984?
Offer a terse response. 0.97. What is the ratio of the Female students (as % of total students) in Kuwait in 1978 to that in 1984?
Offer a very short reply. 1.48. What is the ratio of the Female students (as % of total students) in Mauritius in 1978 to that in 1984?
Your answer should be compact. 1.25. What is the ratio of the Female students (as % of total students) of Poland in 1978 to that in 1984?
Give a very brief answer. 0.98. What is the ratio of the Female students (as % of total students) of World in 1979 to that in 1984?
Provide a succinct answer. 0.98. What is the ratio of the Female students (as % of total students) in Kuwait in 1979 to that in 1984?
Ensure brevity in your answer.  0.64. What is the ratio of the Female students (as % of total students) of Mauritius in 1979 to that in 1984?
Make the answer very short. 1.38. What is the ratio of the Female students (as % of total students) in Poland in 1979 to that in 1984?
Provide a short and direct response. 0.99. What is the difference between the highest and the second highest Female students (as % of total students) in World?
Your answer should be very brief. 0.75. What is the difference between the highest and the second highest Female students (as % of total students) in Kuwait?
Provide a succinct answer. 11.62. What is the difference between the highest and the second highest Female students (as % of total students) in Mauritius?
Keep it short and to the point. 3.85. What is the difference between the highest and the second highest Female students (as % of total students) in Poland?
Keep it short and to the point. 0.62. What is the difference between the highest and the lowest Female students (as % of total students) in World?
Provide a short and direct response. 2.26. What is the difference between the highest and the lowest Female students (as % of total students) of Kuwait?
Ensure brevity in your answer.  22.92. What is the difference between the highest and the lowest Female students (as % of total students) in Mauritius?
Offer a terse response. 13.15. What is the difference between the highest and the lowest Female students (as % of total students) in Poland?
Your answer should be very brief. 1.69. 